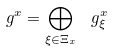<formula> <loc_0><loc_0><loc_500><loc_500>\ g ^ { x } = \bigoplus _ { \xi \in \Xi _ { x } } \, \ g ^ { x } _ { \xi }</formula> 